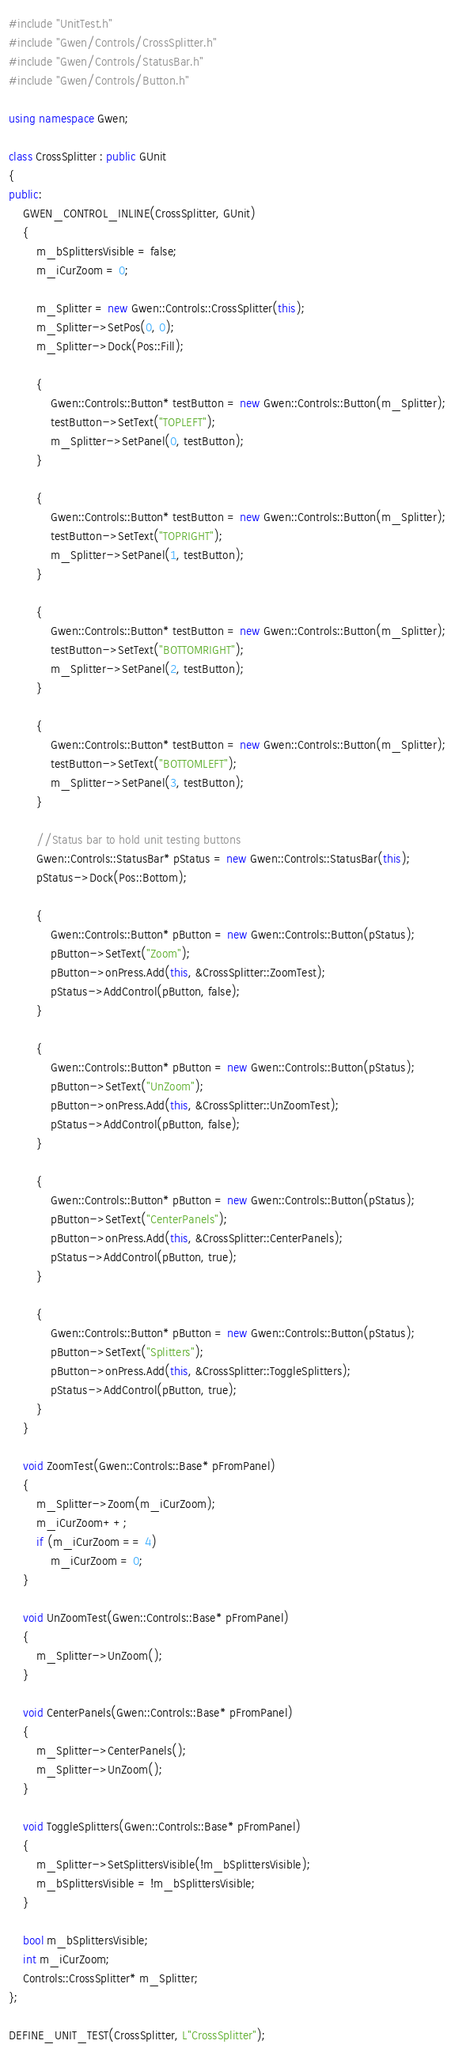Convert code to text. <code><loc_0><loc_0><loc_500><loc_500><_C++_>#include "UnitTest.h"
#include "Gwen/Controls/CrossSplitter.h"
#include "Gwen/Controls/StatusBar.h"
#include "Gwen/Controls/Button.h"

using namespace Gwen;

class CrossSplitter : public GUnit
{
public:
	GWEN_CONTROL_INLINE(CrossSplitter, GUnit)
	{
		m_bSplittersVisible = false;
		m_iCurZoom = 0;

		m_Splitter = new Gwen::Controls::CrossSplitter(this);
		m_Splitter->SetPos(0, 0);
		m_Splitter->Dock(Pos::Fill);

		{
			Gwen::Controls::Button* testButton = new Gwen::Controls::Button(m_Splitter);
			testButton->SetText("TOPLEFT");
			m_Splitter->SetPanel(0, testButton);
		}

		{
			Gwen::Controls::Button* testButton = new Gwen::Controls::Button(m_Splitter);
			testButton->SetText("TOPRIGHT");
			m_Splitter->SetPanel(1, testButton);
		}

		{
			Gwen::Controls::Button* testButton = new Gwen::Controls::Button(m_Splitter);
			testButton->SetText("BOTTOMRIGHT");
			m_Splitter->SetPanel(2, testButton);
		}

		{
			Gwen::Controls::Button* testButton = new Gwen::Controls::Button(m_Splitter);
			testButton->SetText("BOTTOMLEFT");
			m_Splitter->SetPanel(3, testButton);
		}

		//Status bar to hold unit testing buttons
		Gwen::Controls::StatusBar* pStatus = new Gwen::Controls::StatusBar(this);
		pStatus->Dock(Pos::Bottom);

		{
			Gwen::Controls::Button* pButton = new Gwen::Controls::Button(pStatus);
			pButton->SetText("Zoom");
			pButton->onPress.Add(this, &CrossSplitter::ZoomTest);
			pStatus->AddControl(pButton, false);
		}

		{
			Gwen::Controls::Button* pButton = new Gwen::Controls::Button(pStatus);
			pButton->SetText("UnZoom");
			pButton->onPress.Add(this, &CrossSplitter::UnZoomTest);
			pStatus->AddControl(pButton, false);
		}

		{
			Gwen::Controls::Button* pButton = new Gwen::Controls::Button(pStatus);
			pButton->SetText("CenterPanels");
			pButton->onPress.Add(this, &CrossSplitter::CenterPanels);
			pStatus->AddControl(pButton, true);
		}

		{
			Gwen::Controls::Button* pButton = new Gwen::Controls::Button(pStatus);
			pButton->SetText("Splitters");
			pButton->onPress.Add(this, &CrossSplitter::ToggleSplitters);
			pStatus->AddControl(pButton, true);
		}
	}

	void ZoomTest(Gwen::Controls::Base* pFromPanel)
	{
		m_Splitter->Zoom(m_iCurZoom);
		m_iCurZoom++;
		if (m_iCurZoom == 4)
			m_iCurZoom = 0;
	}

	void UnZoomTest(Gwen::Controls::Base* pFromPanel)
	{
		m_Splitter->UnZoom();
	}

	void CenterPanels(Gwen::Controls::Base* pFromPanel)
	{
		m_Splitter->CenterPanels();
		m_Splitter->UnZoom();
	}

	void ToggleSplitters(Gwen::Controls::Base* pFromPanel)
	{
		m_Splitter->SetSplittersVisible(!m_bSplittersVisible);
		m_bSplittersVisible = !m_bSplittersVisible;
	}

	bool m_bSplittersVisible;
	int m_iCurZoom;
	Controls::CrossSplitter* m_Splitter;
};

DEFINE_UNIT_TEST(CrossSplitter, L"CrossSplitter");</code> 